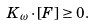Convert formula to latex. <formula><loc_0><loc_0><loc_500><loc_500>K _ { \omega } \cdot [ F ] \geq 0 .</formula> 